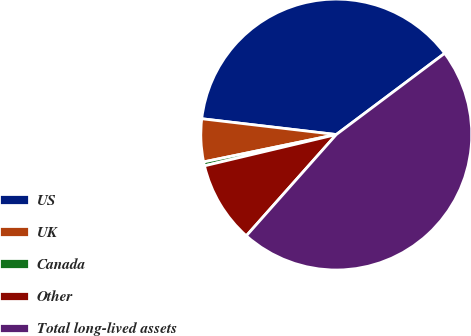Convert chart. <chart><loc_0><loc_0><loc_500><loc_500><pie_chart><fcel>US<fcel>UK<fcel>Canada<fcel>Other<fcel>Total long-lived assets<nl><fcel>37.9%<fcel>5.1%<fcel>0.47%<fcel>9.73%<fcel>46.79%<nl></chart> 